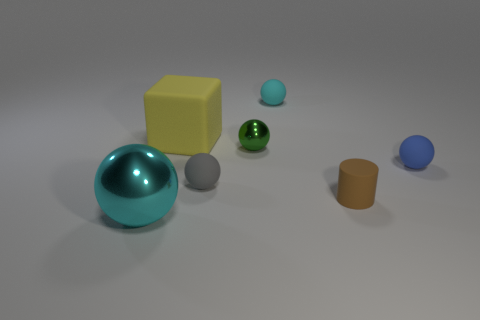Are there more tiny green metallic things to the right of the green sphere than gray spheres?
Make the answer very short. No. How many small blue things are in front of the metal thing that is to the right of the cyan thing in front of the small cyan matte ball?
Ensure brevity in your answer.  1. The thing that is both to the left of the small cyan rubber ball and in front of the small gray matte sphere is made of what material?
Provide a succinct answer. Metal. The big block is what color?
Provide a short and direct response. Yellow. Is the number of gray rubber balls in front of the gray matte sphere greater than the number of green objects right of the tiny brown matte object?
Ensure brevity in your answer.  No. What is the color of the metallic sphere on the right side of the big block?
Make the answer very short. Green. There is a cyan ball behind the blue matte thing; is it the same size as the metal sphere to the left of the large cube?
Your answer should be compact. No. How many things are either small gray rubber objects or blue matte cubes?
Your answer should be very brief. 1. What material is the cylinder that is in front of the metal thing behind the small gray sphere?
Ensure brevity in your answer.  Rubber. How many small shiny things are the same shape as the brown matte object?
Your response must be concise. 0. 